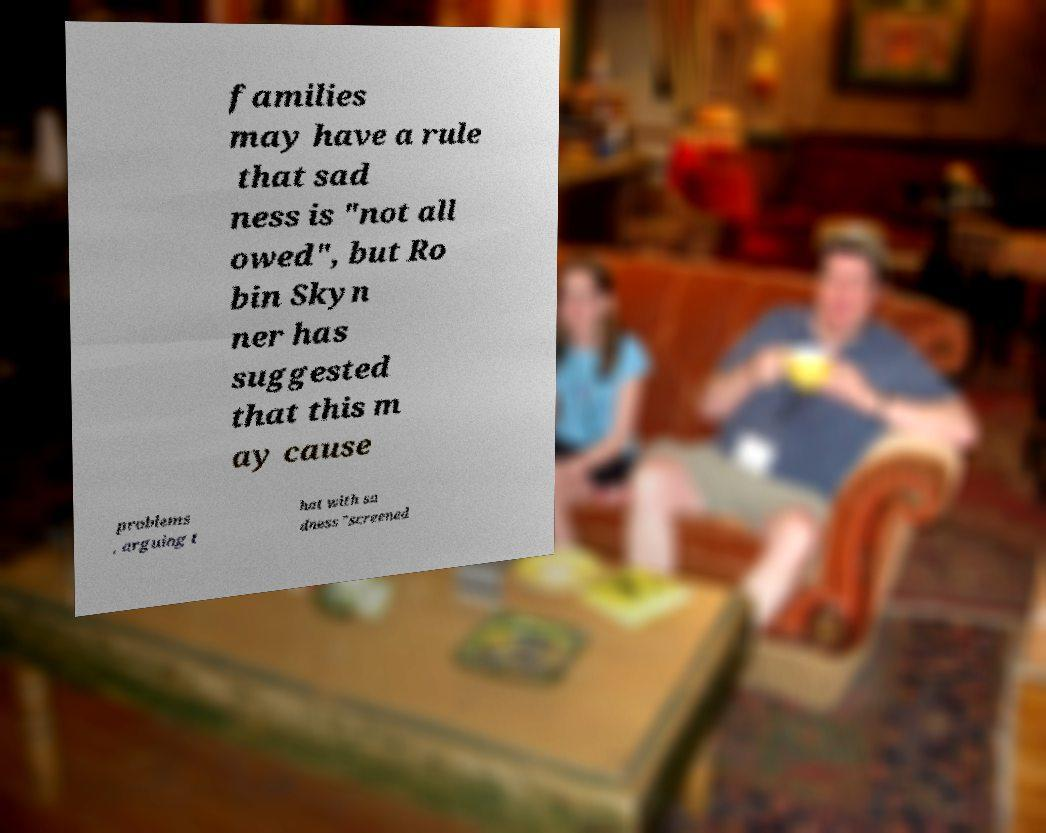What messages or text are displayed in this image? I need them in a readable, typed format. families may have a rule that sad ness is "not all owed", but Ro bin Skyn ner has suggested that this m ay cause problems , arguing t hat with sa dness "screened 